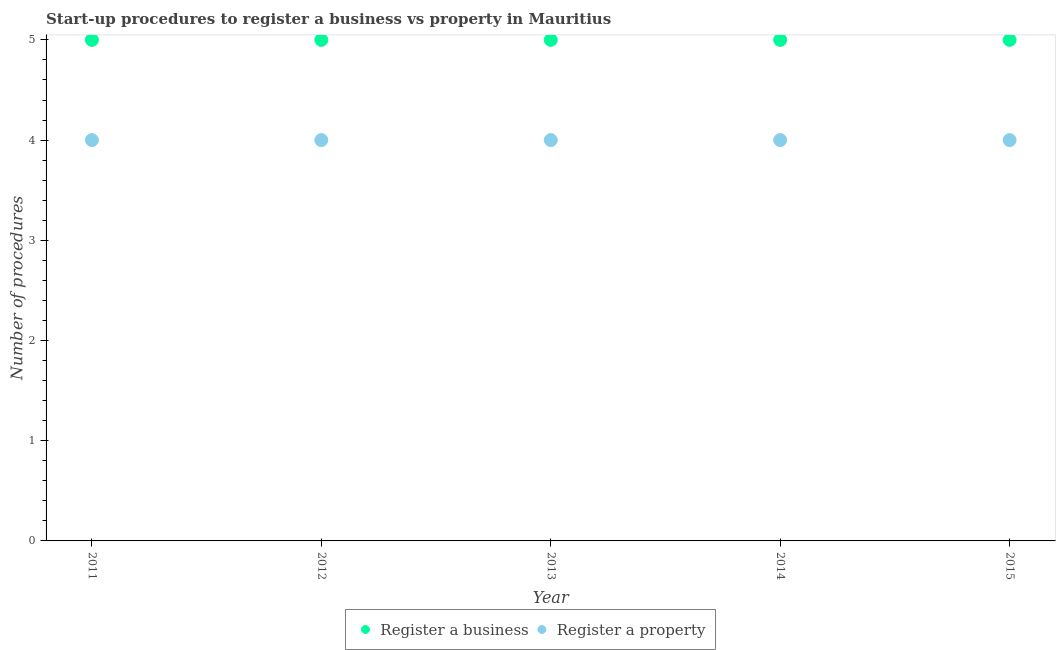Is the number of dotlines equal to the number of legend labels?
Make the answer very short. Yes. What is the number of procedures to register a business in 2012?
Provide a succinct answer. 5. Across all years, what is the maximum number of procedures to register a business?
Your answer should be compact. 5. Across all years, what is the minimum number of procedures to register a property?
Ensure brevity in your answer.  4. In which year was the number of procedures to register a business minimum?
Give a very brief answer. 2011. What is the total number of procedures to register a business in the graph?
Offer a terse response. 25. What is the difference between the number of procedures to register a property in 2012 and that in 2015?
Provide a succinct answer. 0. What is the difference between the number of procedures to register a property in 2013 and the number of procedures to register a business in 2012?
Provide a succinct answer. -1. In the year 2014, what is the difference between the number of procedures to register a property and number of procedures to register a business?
Offer a very short reply. -1. In how many years, is the number of procedures to register a business greater than 0.2?
Give a very brief answer. 5. Is the number of procedures to register a property in 2011 less than that in 2013?
Provide a succinct answer. No. Is the difference between the number of procedures to register a property in 2012 and 2015 greater than the difference between the number of procedures to register a business in 2012 and 2015?
Offer a terse response. No. What is the difference between the highest and the second highest number of procedures to register a property?
Offer a terse response. 0. Is the number of procedures to register a property strictly greater than the number of procedures to register a business over the years?
Give a very brief answer. No. Is the number of procedures to register a business strictly less than the number of procedures to register a property over the years?
Offer a terse response. No. What is the difference between two consecutive major ticks on the Y-axis?
Ensure brevity in your answer.  1. Are the values on the major ticks of Y-axis written in scientific E-notation?
Offer a very short reply. No. Does the graph contain grids?
Your response must be concise. No. Where does the legend appear in the graph?
Offer a very short reply. Bottom center. What is the title of the graph?
Provide a succinct answer. Start-up procedures to register a business vs property in Mauritius. What is the label or title of the Y-axis?
Your response must be concise. Number of procedures. What is the Number of procedures of Register a business in 2011?
Give a very brief answer. 5. What is the Number of procedures of Register a business in 2013?
Provide a short and direct response. 5. What is the Number of procedures of Register a business in 2014?
Your response must be concise. 5. What is the Number of procedures in Register a property in 2014?
Provide a short and direct response. 4. What is the Number of procedures of Register a business in 2015?
Make the answer very short. 5. Across all years, what is the minimum Number of procedures in Register a property?
Your response must be concise. 4. What is the total Number of procedures in Register a business in the graph?
Provide a succinct answer. 25. What is the difference between the Number of procedures in Register a business in 2011 and that in 2012?
Your answer should be compact. 0. What is the difference between the Number of procedures of Register a property in 2011 and that in 2012?
Your response must be concise. 0. What is the difference between the Number of procedures of Register a property in 2011 and that in 2013?
Offer a very short reply. 0. What is the difference between the Number of procedures in Register a business in 2011 and that in 2014?
Provide a short and direct response. 0. What is the difference between the Number of procedures in Register a property in 2011 and that in 2014?
Provide a short and direct response. 0. What is the difference between the Number of procedures in Register a property in 2011 and that in 2015?
Your answer should be very brief. 0. What is the difference between the Number of procedures in Register a property in 2012 and that in 2013?
Your answer should be very brief. 0. What is the difference between the Number of procedures of Register a business in 2012 and that in 2014?
Offer a very short reply. 0. What is the difference between the Number of procedures of Register a property in 2012 and that in 2014?
Provide a succinct answer. 0. What is the difference between the Number of procedures in Register a business in 2013 and that in 2015?
Provide a short and direct response. 0. What is the difference between the Number of procedures in Register a business in 2011 and the Number of procedures in Register a property in 2012?
Your response must be concise. 1. What is the difference between the Number of procedures of Register a business in 2011 and the Number of procedures of Register a property in 2015?
Provide a succinct answer. 1. What is the difference between the Number of procedures in Register a business in 2012 and the Number of procedures in Register a property in 2013?
Provide a succinct answer. 1. What is the difference between the Number of procedures of Register a business in 2012 and the Number of procedures of Register a property in 2014?
Offer a very short reply. 1. What is the difference between the Number of procedures of Register a business in 2012 and the Number of procedures of Register a property in 2015?
Offer a terse response. 1. What is the difference between the Number of procedures in Register a business in 2013 and the Number of procedures in Register a property in 2014?
Your response must be concise. 1. What is the difference between the Number of procedures of Register a business in 2013 and the Number of procedures of Register a property in 2015?
Your response must be concise. 1. What is the average Number of procedures of Register a business per year?
Make the answer very short. 5. What is the average Number of procedures in Register a property per year?
Offer a very short reply. 4. In the year 2012, what is the difference between the Number of procedures in Register a business and Number of procedures in Register a property?
Offer a terse response. 1. In the year 2013, what is the difference between the Number of procedures in Register a business and Number of procedures in Register a property?
Provide a succinct answer. 1. In the year 2014, what is the difference between the Number of procedures in Register a business and Number of procedures in Register a property?
Keep it short and to the point. 1. What is the ratio of the Number of procedures in Register a business in 2011 to that in 2012?
Offer a very short reply. 1. What is the ratio of the Number of procedures in Register a business in 2011 to that in 2013?
Provide a short and direct response. 1. What is the ratio of the Number of procedures of Register a property in 2011 to that in 2013?
Give a very brief answer. 1. What is the ratio of the Number of procedures in Register a business in 2011 to that in 2015?
Make the answer very short. 1. What is the ratio of the Number of procedures of Register a business in 2012 to that in 2013?
Offer a terse response. 1. What is the ratio of the Number of procedures of Register a business in 2012 to that in 2014?
Offer a very short reply. 1. What is the ratio of the Number of procedures in Register a property in 2012 to that in 2014?
Your answer should be compact. 1. What is the ratio of the Number of procedures of Register a property in 2012 to that in 2015?
Ensure brevity in your answer.  1. What is the ratio of the Number of procedures in Register a business in 2013 to that in 2014?
Offer a very short reply. 1. What is the ratio of the Number of procedures in Register a business in 2013 to that in 2015?
Your response must be concise. 1. What is the ratio of the Number of procedures of Register a property in 2014 to that in 2015?
Your answer should be very brief. 1. What is the difference between the highest and the second highest Number of procedures of Register a property?
Offer a very short reply. 0. 